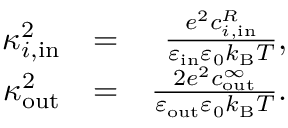Convert formula to latex. <formula><loc_0><loc_0><loc_500><loc_500>\begin{array} { r l r } { \kappa _ { i , i n } ^ { 2 } } & { = } & { \frac { e ^ { 2 } c _ { i , i n } ^ { R } } { \varepsilon _ { i n } \varepsilon _ { 0 } k _ { B } T } , } \\ { \kappa _ { o u t } ^ { 2 } } & { = } & { \frac { 2 e ^ { 2 } c _ { o u t } ^ { \infty } } { \varepsilon _ { o u t } \varepsilon _ { 0 } k _ { B } T } . } \end{array}</formula> 